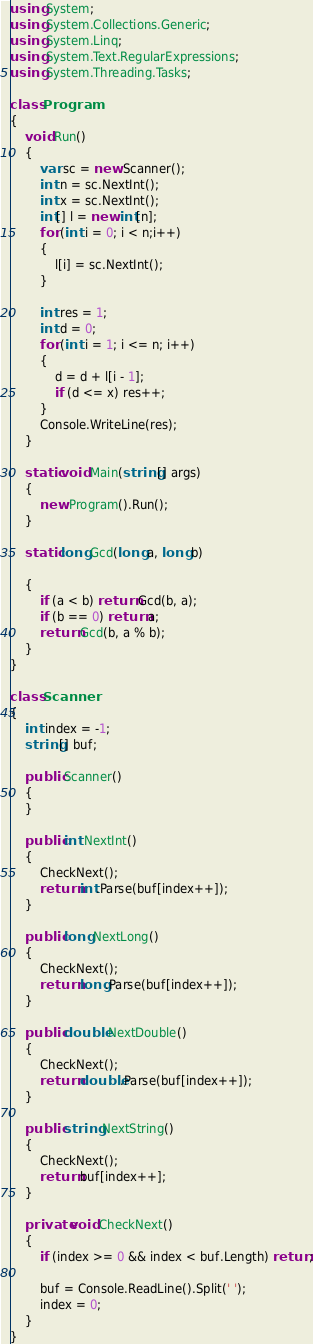<code> <loc_0><loc_0><loc_500><loc_500><_C#_>using System;
using System.Collections.Generic;
using System.Linq;
using System.Text.RegularExpressions;
using System.Threading.Tasks;

class Program
{
    void Run()
    {
        var sc = new Scanner();
        int n = sc.NextInt();
        int x = sc.NextInt();
        int[] l = new int[n];
        for (int i = 0; i < n;i++)
        {
            l[i] = sc.NextInt();
        }

        int res = 1;
        int d = 0;
        for (int i = 1; i <= n; i++)
        {
            d = d + l[i - 1];
            if (d <= x) res++;
        }
        Console.WriteLine(res);
    }

    static void Main(string[] args)
    {
        new Program().Run();
    }

    static long Gcd(long a, long b)

    {
        if (a < b) return Gcd(b, a);
        if (b == 0) return a;
        return Gcd(b, a % b);
    }
}

class Scanner
{
    int index = -1;
    string[] buf;

    public Scanner()
    {
    }

    public int NextInt()
    {
        CheckNext();
        return int.Parse(buf[index++]);
    }

    public long NextLong()
    {
        CheckNext();
        return long.Parse(buf[index++]);
    }

    public double NextDouble()
    {
        CheckNext();
        return double.Parse(buf[index++]);
    }

    public string NextString()
    {
        CheckNext();
        return buf[index++];
    }

    private void CheckNext()
    {
        if (index >= 0 && index < buf.Length) return;

        buf = Console.ReadLine().Split(' ');
        index = 0;
    }
}
</code> 